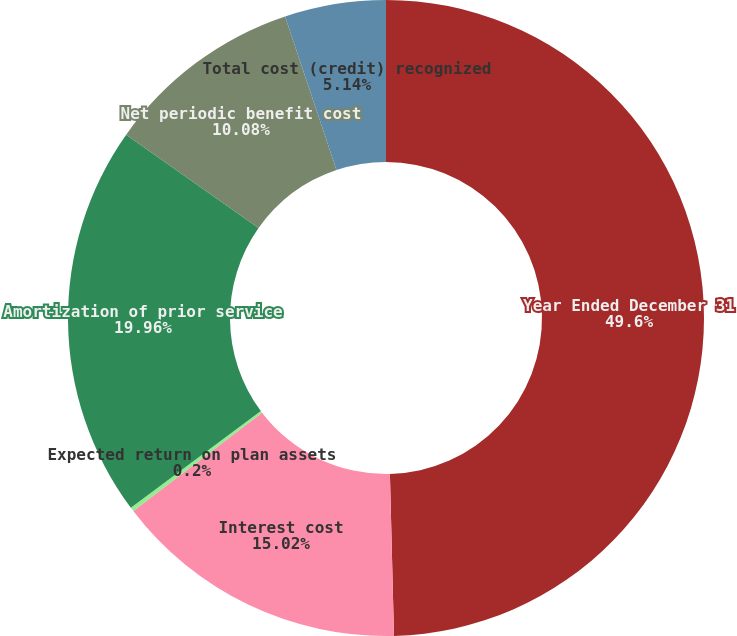Convert chart. <chart><loc_0><loc_0><loc_500><loc_500><pie_chart><fcel>Year Ended December 31<fcel>Interest cost<fcel>Expected return on plan assets<fcel>Amortization of prior service<fcel>Net periodic benefit cost<fcel>Total cost (credit) recognized<nl><fcel>49.6%<fcel>15.02%<fcel>0.2%<fcel>19.96%<fcel>10.08%<fcel>5.14%<nl></chart> 